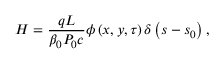Convert formula to latex. <formula><loc_0><loc_0><loc_500><loc_500>H = \frac { q L } { \beta _ { 0 } P _ { 0 } c } \phi \left ( x , y , \tau \right ) \delta \left ( s - s _ { 0 } \right ) ,</formula> 